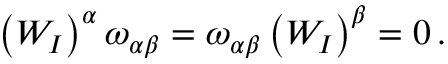Convert formula to latex. <formula><loc_0><loc_0><loc_500><loc_500>\begin{array} { r } { \left ( W _ { I } \right ) ^ { \alpha } \omega _ { \alpha \beta } = \omega _ { \alpha \beta } \left ( W _ { I } \right ) ^ { \beta } = 0 \, . } \end{array}</formula> 